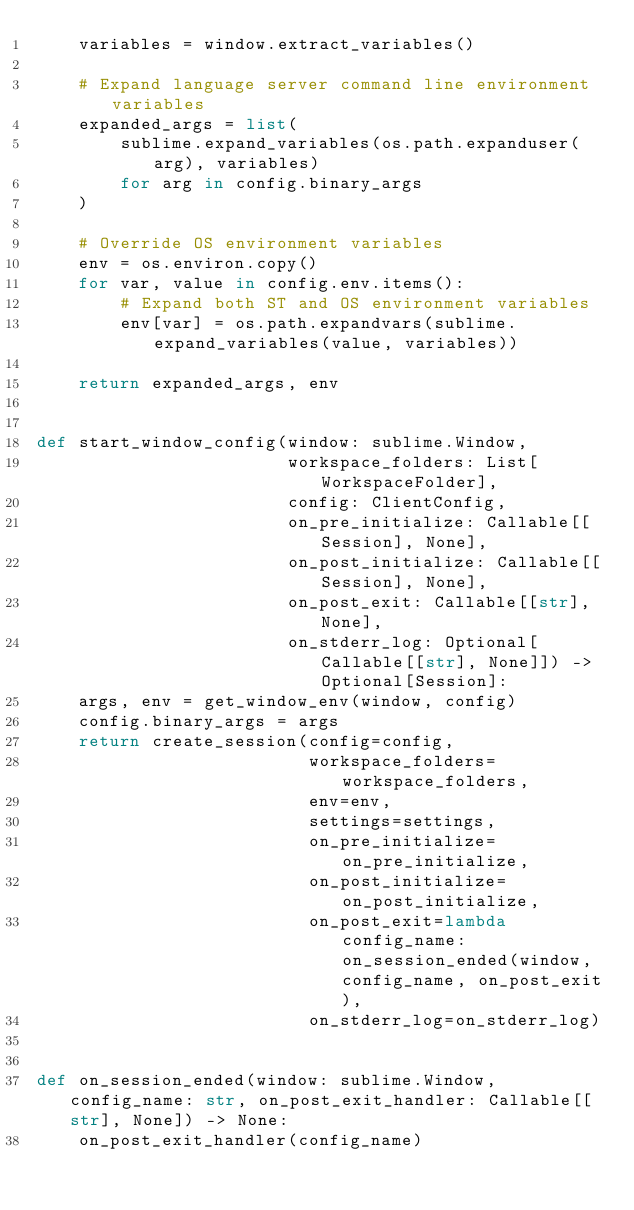<code> <loc_0><loc_0><loc_500><loc_500><_Python_>    variables = window.extract_variables()

    # Expand language server command line environment variables
    expanded_args = list(
        sublime.expand_variables(os.path.expanduser(arg), variables)
        for arg in config.binary_args
    )

    # Override OS environment variables
    env = os.environ.copy()
    for var, value in config.env.items():
        # Expand both ST and OS environment variables
        env[var] = os.path.expandvars(sublime.expand_variables(value, variables))

    return expanded_args, env


def start_window_config(window: sublime.Window,
                        workspace_folders: List[WorkspaceFolder],
                        config: ClientConfig,
                        on_pre_initialize: Callable[[Session], None],
                        on_post_initialize: Callable[[Session], None],
                        on_post_exit: Callable[[str], None],
                        on_stderr_log: Optional[Callable[[str], None]]) -> Optional[Session]:
    args, env = get_window_env(window, config)
    config.binary_args = args
    return create_session(config=config,
                          workspace_folders=workspace_folders,
                          env=env,
                          settings=settings,
                          on_pre_initialize=on_pre_initialize,
                          on_post_initialize=on_post_initialize,
                          on_post_exit=lambda config_name: on_session_ended(window, config_name, on_post_exit),
                          on_stderr_log=on_stderr_log)


def on_session_ended(window: sublime.Window, config_name: str, on_post_exit_handler: Callable[[str], None]) -> None:
    on_post_exit_handler(config_name)
</code> 